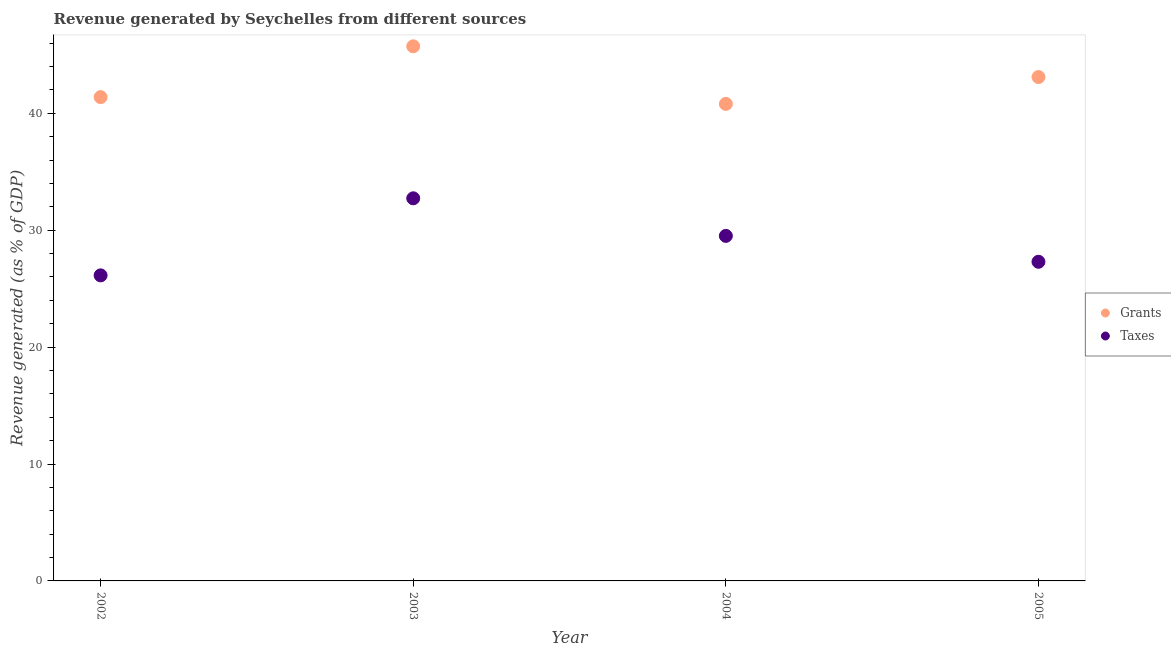Is the number of dotlines equal to the number of legend labels?
Offer a very short reply. Yes. What is the revenue generated by taxes in 2003?
Give a very brief answer. 32.73. Across all years, what is the maximum revenue generated by grants?
Provide a short and direct response. 45.73. Across all years, what is the minimum revenue generated by grants?
Make the answer very short. 40.81. In which year was the revenue generated by grants maximum?
Provide a short and direct response. 2003. In which year was the revenue generated by taxes minimum?
Offer a very short reply. 2002. What is the total revenue generated by grants in the graph?
Your response must be concise. 171.02. What is the difference between the revenue generated by grants in 2003 and that in 2004?
Offer a terse response. 4.92. What is the difference between the revenue generated by grants in 2002 and the revenue generated by taxes in 2005?
Offer a very short reply. 14.08. What is the average revenue generated by taxes per year?
Offer a terse response. 28.92. In the year 2003, what is the difference between the revenue generated by taxes and revenue generated by grants?
Give a very brief answer. -13. In how many years, is the revenue generated by taxes greater than 22 %?
Ensure brevity in your answer.  4. What is the ratio of the revenue generated by taxes in 2004 to that in 2005?
Make the answer very short. 1.08. Is the revenue generated by grants in 2002 less than that in 2004?
Offer a very short reply. No. Is the difference between the revenue generated by grants in 2002 and 2005 greater than the difference between the revenue generated by taxes in 2002 and 2005?
Ensure brevity in your answer.  No. What is the difference between the highest and the second highest revenue generated by taxes?
Your response must be concise. 3.21. What is the difference between the highest and the lowest revenue generated by grants?
Give a very brief answer. 4.92. Is the revenue generated by taxes strictly greater than the revenue generated by grants over the years?
Your response must be concise. No. Is the revenue generated by taxes strictly less than the revenue generated by grants over the years?
Keep it short and to the point. Yes. Are the values on the major ticks of Y-axis written in scientific E-notation?
Make the answer very short. No. Does the graph contain any zero values?
Provide a succinct answer. No. What is the title of the graph?
Provide a short and direct response. Revenue generated by Seychelles from different sources. Does "Attending school" appear as one of the legend labels in the graph?
Your answer should be very brief. No. What is the label or title of the Y-axis?
Ensure brevity in your answer.  Revenue generated (as % of GDP). What is the Revenue generated (as % of GDP) in Grants in 2002?
Offer a terse response. 41.38. What is the Revenue generated (as % of GDP) in Taxes in 2002?
Your answer should be compact. 26.14. What is the Revenue generated (as % of GDP) in Grants in 2003?
Offer a very short reply. 45.73. What is the Revenue generated (as % of GDP) of Taxes in 2003?
Ensure brevity in your answer.  32.73. What is the Revenue generated (as % of GDP) of Grants in 2004?
Provide a short and direct response. 40.81. What is the Revenue generated (as % of GDP) in Taxes in 2004?
Keep it short and to the point. 29.52. What is the Revenue generated (as % of GDP) of Grants in 2005?
Provide a short and direct response. 43.1. What is the Revenue generated (as % of GDP) of Taxes in 2005?
Provide a short and direct response. 27.3. Across all years, what is the maximum Revenue generated (as % of GDP) in Grants?
Offer a very short reply. 45.73. Across all years, what is the maximum Revenue generated (as % of GDP) of Taxes?
Your answer should be compact. 32.73. Across all years, what is the minimum Revenue generated (as % of GDP) in Grants?
Provide a short and direct response. 40.81. Across all years, what is the minimum Revenue generated (as % of GDP) in Taxes?
Your answer should be compact. 26.14. What is the total Revenue generated (as % of GDP) of Grants in the graph?
Provide a short and direct response. 171.02. What is the total Revenue generated (as % of GDP) of Taxes in the graph?
Your response must be concise. 115.68. What is the difference between the Revenue generated (as % of GDP) in Grants in 2002 and that in 2003?
Give a very brief answer. -4.34. What is the difference between the Revenue generated (as % of GDP) in Taxes in 2002 and that in 2003?
Provide a succinct answer. -6.59. What is the difference between the Revenue generated (as % of GDP) of Grants in 2002 and that in 2004?
Offer a terse response. 0.58. What is the difference between the Revenue generated (as % of GDP) of Taxes in 2002 and that in 2004?
Keep it short and to the point. -3.38. What is the difference between the Revenue generated (as % of GDP) of Grants in 2002 and that in 2005?
Provide a short and direct response. -1.72. What is the difference between the Revenue generated (as % of GDP) in Taxes in 2002 and that in 2005?
Your response must be concise. -1.16. What is the difference between the Revenue generated (as % of GDP) of Grants in 2003 and that in 2004?
Give a very brief answer. 4.92. What is the difference between the Revenue generated (as % of GDP) in Taxes in 2003 and that in 2004?
Provide a succinct answer. 3.21. What is the difference between the Revenue generated (as % of GDP) in Grants in 2003 and that in 2005?
Ensure brevity in your answer.  2.63. What is the difference between the Revenue generated (as % of GDP) in Taxes in 2003 and that in 2005?
Offer a terse response. 5.43. What is the difference between the Revenue generated (as % of GDP) in Grants in 2004 and that in 2005?
Ensure brevity in your answer.  -2.3. What is the difference between the Revenue generated (as % of GDP) of Taxes in 2004 and that in 2005?
Provide a short and direct response. 2.22. What is the difference between the Revenue generated (as % of GDP) in Grants in 2002 and the Revenue generated (as % of GDP) in Taxes in 2003?
Keep it short and to the point. 8.66. What is the difference between the Revenue generated (as % of GDP) of Grants in 2002 and the Revenue generated (as % of GDP) of Taxes in 2004?
Your answer should be very brief. 11.87. What is the difference between the Revenue generated (as % of GDP) in Grants in 2002 and the Revenue generated (as % of GDP) in Taxes in 2005?
Your response must be concise. 14.09. What is the difference between the Revenue generated (as % of GDP) in Grants in 2003 and the Revenue generated (as % of GDP) in Taxes in 2004?
Your response must be concise. 16.21. What is the difference between the Revenue generated (as % of GDP) of Grants in 2003 and the Revenue generated (as % of GDP) of Taxes in 2005?
Ensure brevity in your answer.  18.43. What is the difference between the Revenue generated (as % of GDP) of Grants in 2004 and the Revenue generated (as % of GDP) of Taxes in 2005?
Offer a terse response. 13.51. What is the average Revenue generated (as % of GDP) in Grants per year?
Offer a terse response. 42.76. What is the average Revenue generated (as % of GDP) in Taxes per year?
Your answer should be compact. 28.92. In the year 2002, what is the difference between the Revenue generated (as % of GDP) of Grants and Revenue generated (as % of GDP) of Taxes?
Offer a very short reply. 15.25. In the year 2003, what is the difference between the Revenue generated (as % of GDP) in Grants and Revenue generated (as % of GDP) in Taxes?
Offer a terse response. 13. In the year 2004, what is the difference between the Revenue generated (as % of GDP) in Grants and Revenue generated (as % of GDP) in Taxes?
Offer a terse response. 11.29. In the year 2005, what is the difference between the Revenue generated (as % of GDP) of Grants and Revenue generated (as % of GDP) of Taxes?
Make the answer very short. 15.8. What is the ratio of the Revenue generated (as % of GDP) of Grants in 2002 to that in 2003?
Offer a very short reply. 0.91. What is the ratio of the Revenue generated (as % of GDP) in Taxes in 2002 to that in 2003?
Make the answer very short. 0.8. What is the ratio of the Revenue generated (as % of GDP) in Grants in 2002 to that in 2004?
Provide a short and direct response. 1.01. What is the ratio of the Revenue generated (as % of GDP) in Taxes in 2002 to that in 2004?
Give a very brief answer. 0.89. What is the ratio of the Revenue generated (as % of GDP) in Grants in 2002 to that in 2005?
Make the answer very short. 0.96. What is the ratio of the Revenue generated (as % of GDP) of Taxes in 2002 to that in 2005?
Provide a succinct answer. 0.96. What is the ratio of the Revenue generated (as % of GDP) of Grants in 2003 to that in 2004?
Offer a terse response. 1.12. What is the ratio of the Revenue generated (as % of GDP) in Taxes in 2003 to that in 2004?
Offer a very short reply. 1.11. What is the ratio of the Revenue generated (as % of GDP) in Grants in 2003 to that in 2005?
Offer a very short reply. 1.06. What is the ratio of the Revenue generated (as % of GDP) in Taxes in 2003 to that in 2005?
Give a very brief answer. 1.2. What is the ratio of the Revenue generated (as % of GDP) in Grants in 2004 to that in 2005?
Your response must be concise. 0.95. What is the ratio of the Revenue generated (as % of GDP) in Taxes in 2004 to that in 2005?
Provide a succinct answer. 1.08. What is the difference between the highest and the second highest Revenue generated (as % of GDP) in Grants?
Provide a short and direct response. 2.63. What is the difference between the highest and the second highest Revenue generated (as % of GDP) in Taxes?
Your response must be concise. 3.21. What is the difference between the highest and the lowest Revenue generated (as % of GDP) of Grants?
Your answer should be very brief. 4.92. What is the difference between the highest and the lowest Revenue generated (as % of GDP) in Taxes?
Your response must be concise. 6.59. 